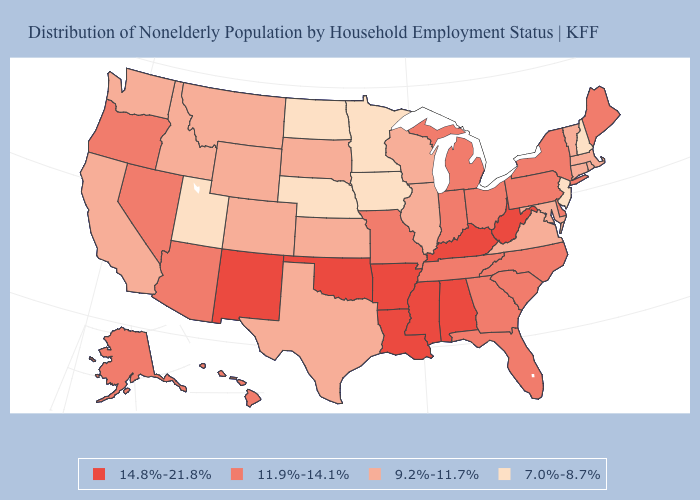Among the states that border Nebraska , which have the lowest value?
Short answer required. Iowa. What is the value of West Virginia?
Concise answer only. 14.8%-21.8%. Does the map have missing data?
Answer briefly. No. Name the states that have a value in the range 7.0%-8.7%?
Give a very brief answer. Iowa, Minnesota, Nebraska, New Hampshire, New Jersey, North Dakota, Utah. What is the highest value in the USA?
Be succinct. 14.8%-21.8%. Does the map have missing data?
Concise answer only. No. Does New Mexico have the highest value in the West?
Write a very short answer. Yes. What is the value of Florida?
Be succinct. 11.9%-14.1%. What is the value of Ohio?
Quick response, please. 11.9%-14.1%. What is the lowest value in the USA?
Quick response, please. 7.0%-8.7%. Name the states that have a value in the range 11.9%-14.1%?
Short answer required. Alaska, Arizona, Delaware, Florida, Georgia, Hawaii, Indiana, Maine, Michigan, Missouri, Nevada, New York, North Carolina, Ohio, Oregon, Pennsylvania, South Carolina, Tennessee. What is the value of Arkansas?
Quick response, please. 14.8%-21.8%. Does the first symbol in the legend represent the smallest category?
Give a very brief answer. No. What is the highest value in the USA?
Write a very short answer. 14.8%-21.8%. What is the value of Colorado?
Concise answer only. 9.2%-11.7%. 